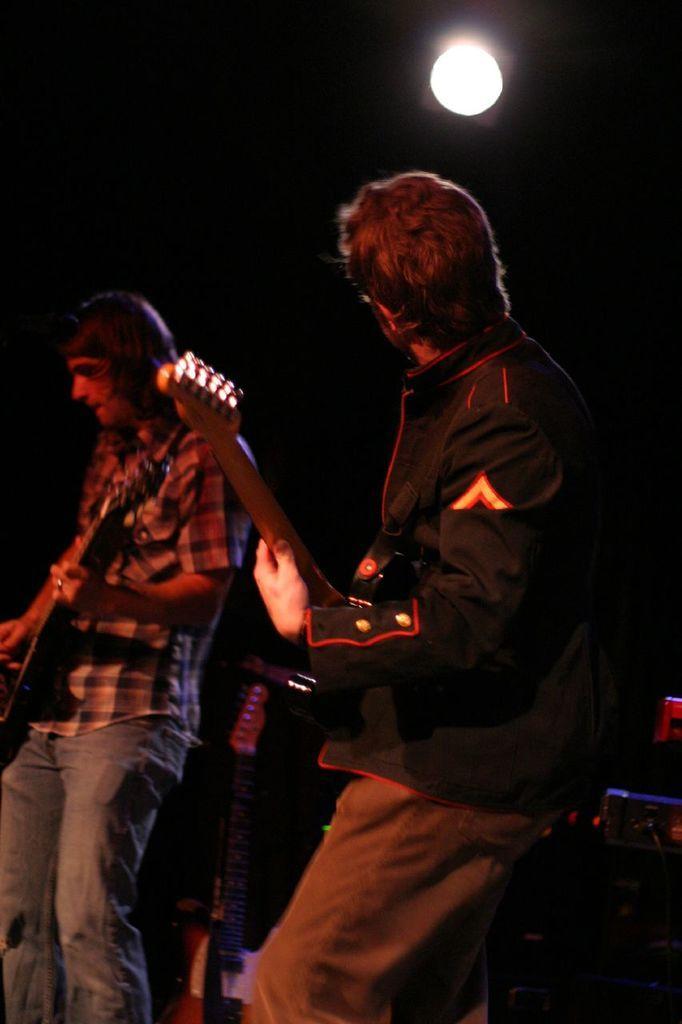Can you describe this image briefly? In this picture we can see two persons are playing guitar. And this is light. 